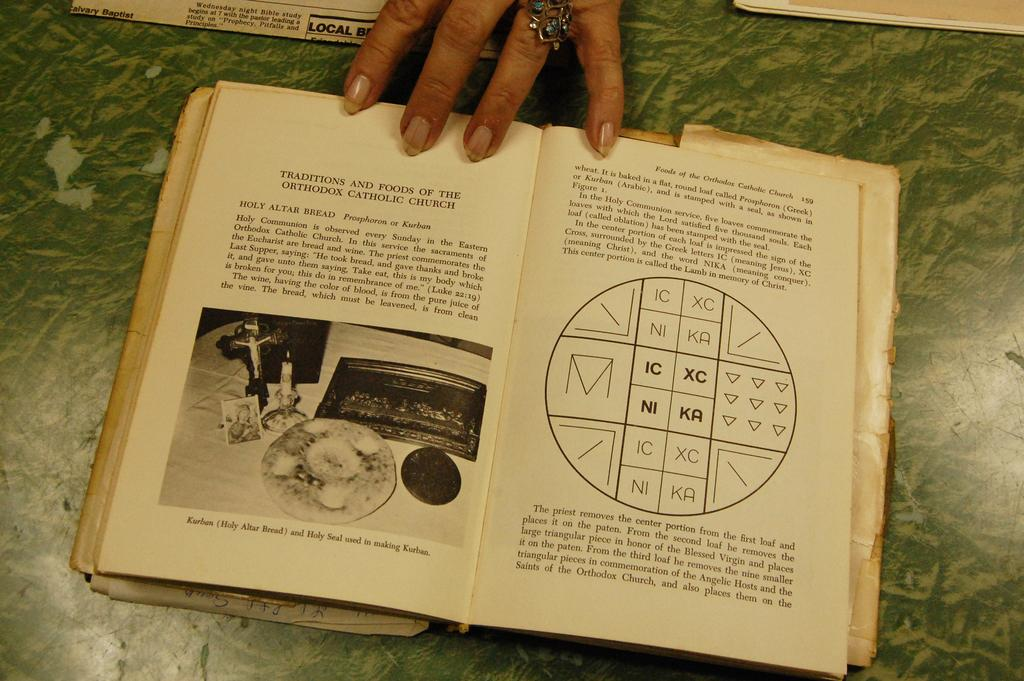<image>
Present a compact description of the photo's key features. Someone holds a book open to a page about the traditions and foods of the Orthodox Catholic Church. 